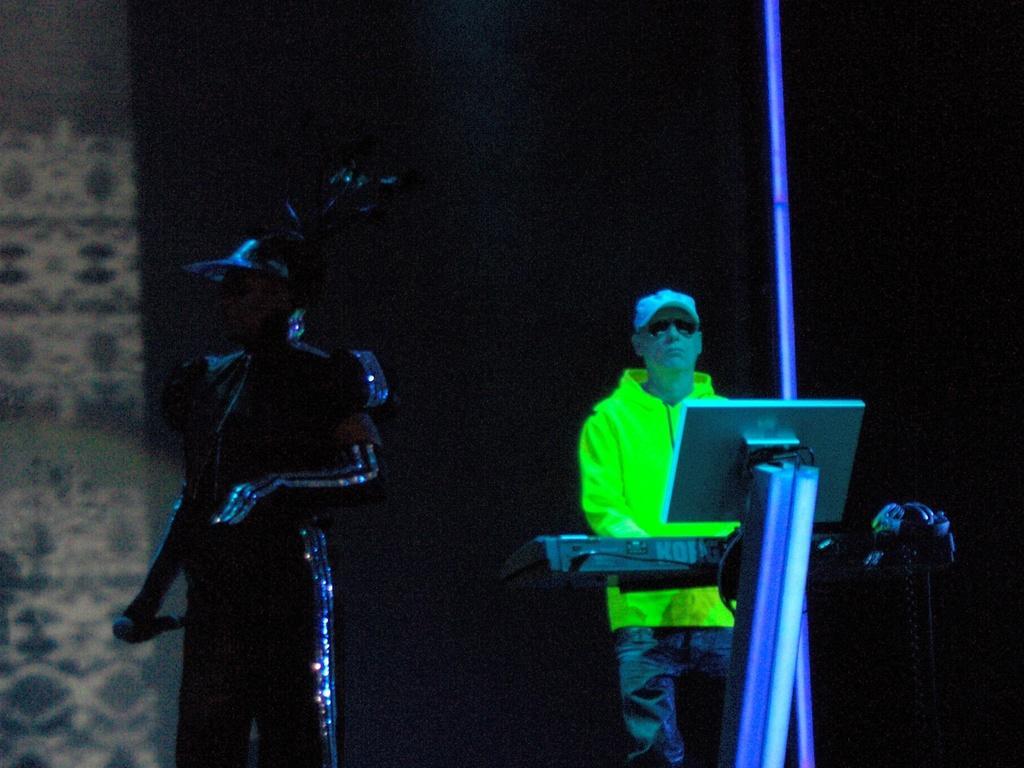Please provide a concise description of this image. In this image, we can see a person wearing costume and a cap and holding a mic and on the right, there is a man wearing a coat, cap and glasses and we can see musical instruments and a pole and the background is dark. 